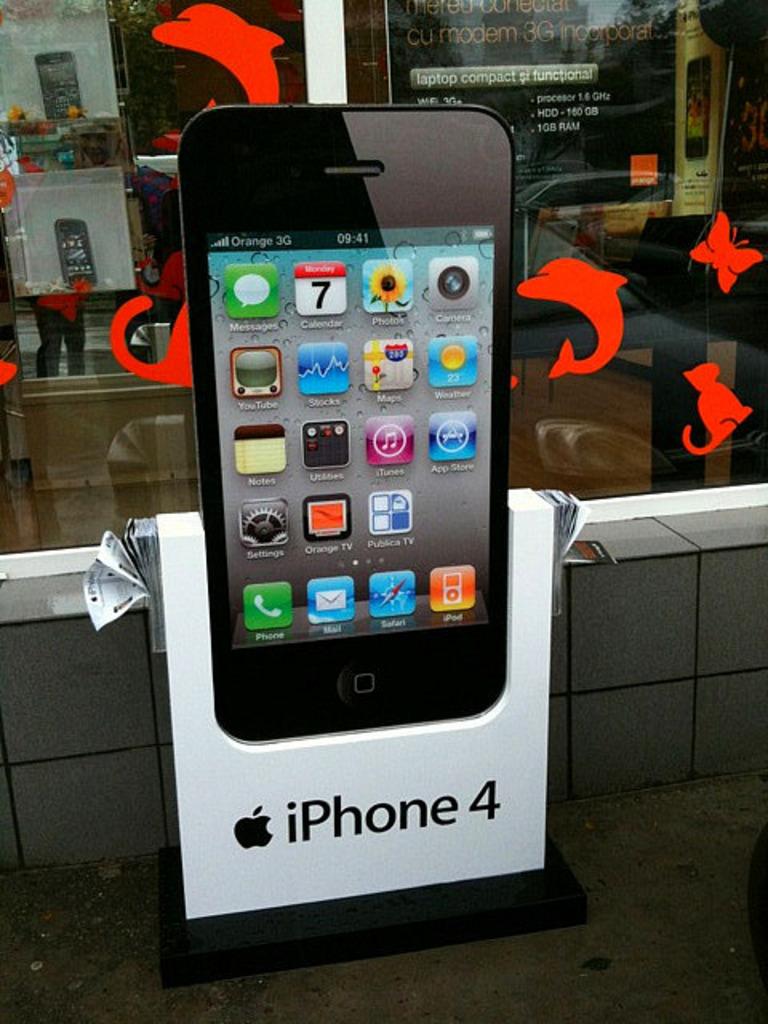What type of iphone is being advertised?
Keep it short and to the point. Iphone 4. What app is in the bottom left corner?
Make the answer very short. Phone. 